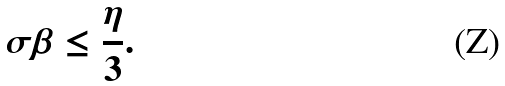<formula> <loc_0><loc_0><loc_500><loc_500>\sigma \beta \leq \frac { \eta } { 3 } .</formula> 